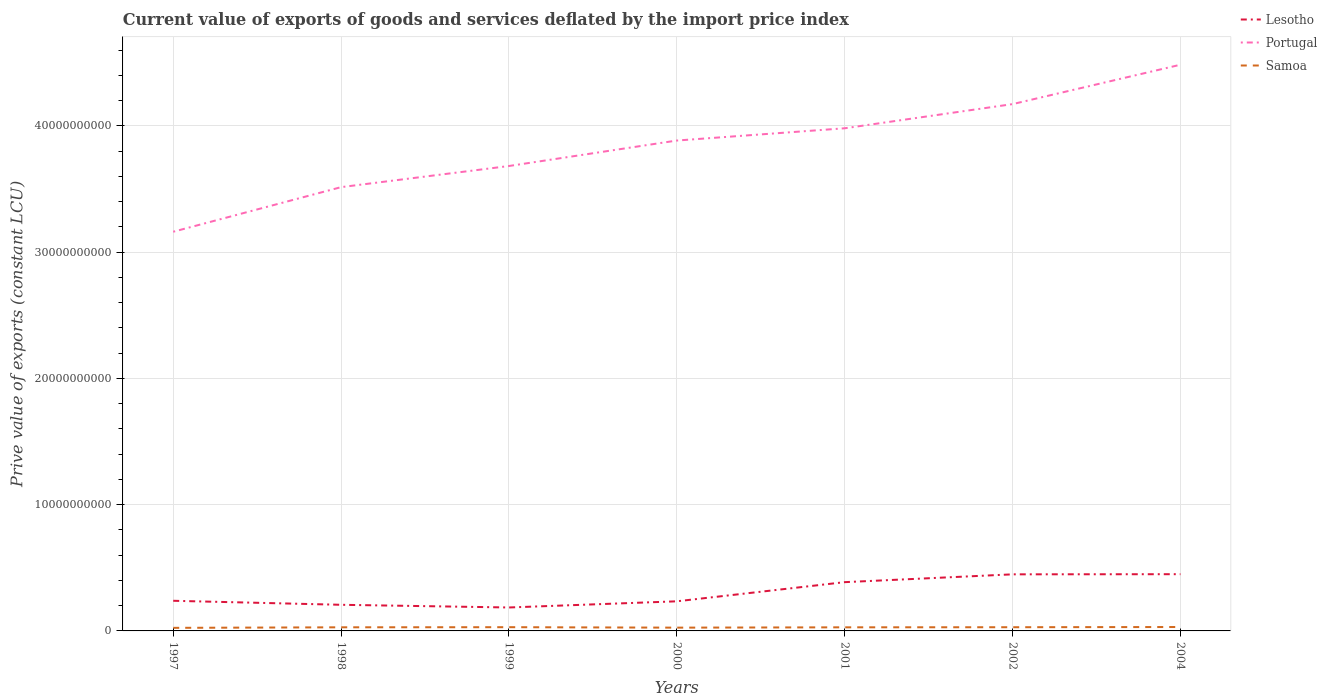How many different coloured lines are there?
Offer a very short reply. 3. Does the line corresponding to Portugal intersect with the line corresponding to Lesotho?
Provide a short and direct response. No. Across all years, what is the maximum prive value of exports in Samoa?
Provide a short and direct response. 2.44e+08. In which year was the prive value of exports in Samoa maximum?
Offer a terse response. 1997. What is the total prive value of exports in Samoa in the graph?
Provide a short and direct response. -2.47e+07. What is the difference between the highest and the second highest prive value of exports in Lesotho?
Your answer should be very brief. 2.64e+09. How many years are there in the graph?
Offer a terse response. 7. Are the values on the major ticks of Y-axis written in scientific E-notation?
Offer a terse response. No. Where does the legend appear in the graph?
Offer a very short reply. Top right. How many legend labels are there?
Offer a very short reply. 3. How are the legend labels stacked?
Your response must be concise. Vertical. What is the title of the graph?
Your answer should be very brief. Current value of exports of goods and services deflated by the import price index. What is the label or title of the X-axis?
Provide a succinct answer. Years. What is the label or title of the Y-axis?
Provide a short and direct response. Prive value of exports (constant LCU). What is the Prive value of exports (constant LCU) in Lesotho in 1997?
Give a very brief answer. 2.39e+09. What is the Prive value of exports (constant LCU) in Portugal in 1997?
Offer a very short reply. 3.16e+1. What is the Prive value of exports (constant LCU) in Samoa in 1997?
Your answer should be very brief. 2.44e+08. What is the Prive value of exports (constant LCU) of Lesotho in 1998?
Give a very brief answer. 2.07e+09. What is the Prive value of exports (constant LCU) in Portugal in 1998?
Keep it short and to the point. 3.52e+1. What is the Prive value of exports (constant LCU) in Samoa in 1998?
Your answer should be compact. 2.86e+08. What is the Prive value of exports (constant LCU) in Lesotho in 1999?
Give a very brief answer. 1.86e+09. What is the Prive value of exports (constant LCU) of Portugal in 1999?
Provide a succinct answer. 3.68e+1. What is the Prive value of exports (constant LCU) of Samoa in 1999?
Your answer should be very brief. 2.95e+08. What is the Prive value of exports (constant LCU) in Lesotho in 2000?
Your answer should be compact. 2.35e+09. What is the Prive value of exports (constant LCU) of Portugal in 2000?
Offer a very short reply. 3.88e+1. What is the Prive value of exports (constant LCU) of Samoa in 2000?
Give a very brief answer. 2.60e+08. What is the Prive value of exports (constant LCU) of Lesotho in 2001?
Give a very brief answer. 3.86e+09. What is the Prive value of exports (constant LCU) of Portugal in 2001?
Offer a very short reply. 3.98e+1. What is the Prive value of exports (constant LCU) in Samoa in 2001?
Make the answer very short. 2.85e+08. What is the Prive value of exports (constant LCU) in Lesotho in 2002?
Make the answer very short. 4.48e+09. What is the Prive value of exports (constant LCU) of Portugal in 2002?
Make the answer very short. 4.17e+1. What is the Prive value of exports (constant LCU) of Samoa in 2002?
Make the answer very short. 2.93e+08. What is the Prive value of exports (constant LCU) of Lesotho in 2004?
Your answer should be very brief. 4.49e+09. What is the Prive value of exports (constant LCU) in Portugal in 2004?
Your answer should be compact. 4.49e+1. What is the Prive value of exports (constant LCU) of Samoa in 2004?
Make the answer very short. 3.10e+08. Across all years, what is the maximum Prive value of exports (constant LCU) of Lesotho?
Your answer should be compact. 4.49e+09. Across all years, what is the maximum Prive value of exports (constant LCU) in Portugal?
Your response must be concise. 4.49e+1. Across all years, what is the maximum Prive value of exports (constant LCU) of Samoa?
Your answer should be very brief. 3.10e+08. Across all years, what is the minimum Prive value of exports (constant LCU) in Lesotho?
Offer a terse response. 1.86e+09. Across all years, what is the minimum Prive value of exports (constant LCU) of Portugal?
Your response must be concise. 3.16e+1. Across all years, what is the minimum Prive value of exports (constant LCU) in Samoa?
Offer a terse response. 2.44e+08. What is the total Prive value of exports (constant LCU) of Lesotho in the graph?
Provide a short and direct response. 2.15e+1. What is the total Prive value of exports (constant LCU) in Portugal in the graph?
Your response must be concise. 2.69e+11. What is the total Prive value of exports (constant LCU) of Samoa in the graph?
Keep it short and to the point. 1.97e+09. What is the difference between the Prive value of exports (constant LCU) of Lesotho in 1997 and that in 1998?
Keep it short and to the point. 3.17e+08. What is the difference between the Prive value of exports (constant LCU) in Portugal in 1997 and that in 1998?
Provide a succinct answer. -3.53e+09. What is the difference between the Prive value of exports (constant LCU) in Samoa in 1997 and that in 1998?
Keep it short and to the point. -4.23e+07. What is the difference between the Prive value of exports (constant LCU) of Lesotho in 1997 and that in 1999?
Provide a short and direct response. 5.31e+08. What is the difference between the Prive value of exports (constant LCU) in Portugal in 1997 and that in 1999?
Your answer should be very brief. -5.21e+09. What is the difference between the Prive value of exports (constant LCU) of Samoa in 1997 and that in 1999?
Make the answer very short. -5.15e+07. What is the difference between the Prive value of exports (constant LCU) of Lesotho in 1997 and that in 2000?
Your answer should be very brief. 4.17e+07. What is the difference between the Prive value of exports (constant LCU) of Portugal in 1997 and that in 2000?
Keep it short and to the point. -7.22e+09. What is the difference between the Prive value of exports (constant LCU) in Samoa in 1997 and that in 2000?
Provide a short and direct response. -1.63e+07. What is the difference between the Prive value of exports (constant LCU) in Lesotho in 1997 and that in 2001?
Provide a short and direct response. -1.48e+09. What is the difference between the Prive value of exports (constant LCU) of Portugal in 1997 and that in 2001?
Ensure brevity in your answer.  -8.20e+09. What is the difference between the Prive value of exports (constant LCU) of Samoa in 1997 and that in 2001?
Make the answer very short. -4.10e+07. What is the difference between the Prive value of exports (constant LCU) in Lesotho in 1997 and that in 2002?
Provide a succinct answer. -2.10e+09. What is the difference between the Prive value of exports (constant LCU) of Portugal in 1997 and that in 2002?
Make the answer very short. -1.01e+1. What is the difference between the Prive value of exports (constant LCU) in Samoa in 1997 and that in 2002?
Give a very brief answer. -4.91e+07. What is the difference between the Prive value of exports (constant LCU) of Lesotho in 1997 and that in 2004?
Your response must be concise. -2.11e+09. What is the difference between the Prive value of exports (constant LCU) in Portugal in 1997 and that in 2004?
Keep it short and to the point. -1.32e+1. What is the difference between the Prive value of exports (constant LCU) of Samoa in 1997 and that in 2004?
Ensure brevity in your answer.  -6.58e+07. What is the difference between the Prive value of exports (constant LCU) of Lesotho in 1998 and that in 1999?
Your response must be concise. 2.13e+08. What is the difference between the Prive value of exports (constant LCU) of Portugal in 1998 and that in 1999?
Keep it short and to the point. -1.67e+09. What is the difference between the Prive value of exports (constant LCU) of Samoa in 1998 and that in 1999?
Provide a succinct answer. -9.18e+06. What is the difference between the Prive value of exports (constant LCU) in Lesotho in 1998 and that in 2000?
Your answer should be compact. -2.76e+08. What is the difference between the Prive value of exports (constant LCU) of Portugal in 1998 and that in 2000?
Provide a succinct answer. -3.69e+09. What is the difference between the Prive value of exports (constant LCU) in Samoa in 1998 and that in 2000?
Ensure brevity in your answer.  2.60e+07. What is the difference between the Prive value of exports (constant LCU) in Lesotho in 1998 and that in 2001?
Keep it short and to the point. -1.79e+09. What is the difference between the Prive value of exports (constant LCU) in Portugal in 1998 and that in 2001?
Keep it short and to the point. -4.66e+09. What is the difference between the Prive value of exports (constant LCU) of Samoa in 1998 and that in 2001?
Give a very brief answer. 1.26e+06. What is the difference between the Prive value of exports (constant LCU) of Lesotho in 1998 and that in 2002?
Your answer should be compact. -2.41e+09. What is the difference between the Prive value of exports (constant LCU) of Portugal in 1998 and that in 2002?
Offer a very short reply. -6.58e+09. What is the difference between the Prive value of exports (constant LCU) of Samoa in 1998 and that in 2002?
Make the answer very short. -6.85e+06. What is the difference between the Prive value of exports (constant LCU) of Lesotho in 1998 and that in 2004?
Your response must be concise. -2.42e+09. What is the difference between the Prive value of exports (constant LCU) of Portugal in 1998 and that in 2004?
Make the answer very short. -9.70e+09. What is the difference between the Prive value of exports (constant LCU) of Samoa in 1998 and that in 2004?
Your answer should be compact. -2.35e+07. What is the difference between the Prive value of exports (constant LCU) in Lesotho in 1999 and that in 2000?
Your answer should be very brief. -4.89e+08. What is the difference between the Prive value of exports (constant LCU) in Portugal in 1999 and that in 2000?
Provide a succinct answer. -2.02e+09. What is the difference between the Prive value of exports (constant LCU) in Samoa in 1999 and that in 2000?
Make the answer very short. 3.52e+07. What is the difference between the Prive value of exports (constant LCU) in Lesotho in 1999 and that in 2001?
Give a very brief answer. -2.01e+09. What is the difference between the Prive value of exports (constant LCU) in Portugal in 1999 and that in 2001?
Provide a succinct answer. -2.99e+09. What is the difference between the Prive value of exports (constant LCU) of Samoa in 1999 and that in 2001?
Ensure brevity in your answer.  1.04e+07. What is the difference between the Prive value of exports (constant LCU) of Lesotho in 1999 and that in 2002?
Your response must be concise. -2.63e+09. What is the difference between the Prive value of exports (constant LCU) in Portugal in 1999 and that in 2002?
Ensure brevity in your answer.  -4.90e+09. What is the difference between the Prive value of exports (constant LCU) in Samoa in 1999 and that in 2002?
Provide a succinct answer. 2.34e+06. What is the difference between the Prive value of exports (constant LCU) of Lesotho in 1999 and that in 2004?
Offer a very short reply. -2.64e+09. What is the difference between the Prive value of exports (constant LCU) of Portugal in 1999 and that in 2004?
Offer a terse response. -8.02e+09. What is the difference between the Prive value of exports (constant LCU) of Samoa in 1999 and that in 2004?
Keep it short and to the point. -1.43e+07. What is the difference between the Prive value of exports (constant LCU) in Lesotho in 2000 and that in 2001?
Offer a very short reply. -1.52e+09. What is the difference between the Prive value of exports (constant LCU) of Portugal in 2000 and that in 2001?
Your response must be concise. -9.72e+08. What is the difference between the Prive value of exports (constant LCU) of Samoa in 2000 and that in 2001?
Offer a terse response. -2.48e+07. What is the difference between the Prive value of exports (constant LCU) of Lesotho in 2000 and that in 2002?
Keep it short and to the point. -2.14e+09. What is the difference between the Prive value of exports (constant LCU) in Portugal in 2000 and that in 2002?
Provide a succinct answer. -2.89e+09. What is the difference between the Prive value of exports (constant LCU) of Samoa in 2000 and that in 2002?
Provide a short and direct response. -3.29e+07. What is the difference between the Prive value of exports (constant LCU) of Lesotho in 2000 and that in 2004?
Your response must be concise. -2.15e+09. What is the difference between the Prive value of exports (constant LCU) in Portugal in 2000 and that in 2004?
Offer a terse response. -6.01e+09. What is the difference between the Prive value of exports (constant LCU) in Samoa in 2000 and that in 2004?
Your answer should be compact. -4.95e+07. What is the difference between the Prive value of exports (constant LCU) in Lesotho in 2001 and that in 2002?
Ensure brevity in your answer.  -6.19e+08. What is the difference between the Prive value of exports (constant LCU) in Portugal in 2001 and that in 2002?
Your answer should be compact. -1.91e+09. What is the difference between the Prive value of exports (constant LCU) of Samoa in 2001 and that in 2002?
Provide a short and direct response. -8.11e+06. What is the difference between the Prive value of exports (constant LCU) of Lesotho in 2001 and that in 2004?
Your answer should be compact. -6.31e+08. What is the difference between the Prive value of exports (constant LCU) of Portugal in 2001 and that in 2004?
Your response must be concise. -5.03e+09. What is the difference between the Prive value of exports (constant LCU) in Samoa in 2001 and that in 2004?
Your answer should be very brief. -2.47e+07. What is the difference between the Prive value of exports (constant LCU) in Lesotho in 2002 and that in 2004?
Your response must be concise. -1.13e+07. What is the difference between the Prive value of exports (constant LCU) of Portugal in 2002 and that in 2004?
Your response must be concise. -3.12e+09. What is the difference between the Prive value of exports (constant LCU) of Samoa in 2002 and that in 2004?
Your answer should be compact. -1.66e+07. What is the difference between the Prive value of exports (constant LCU) of Lesotho in 1997 and the Prive value of exports (constant LCU) of Portugal in 1998?
Your answer should be very brief. -3.28e+1. What is the difference between the Prive value of exports (constant LCU) in Lesotho in 1997 and the Prive value of exports (constant LCU) in Samoa in 1998?
Ensure brevity in your answer.  2.10e+09. What is the difference between the Prive value of exports (constant LCU) in Portugal in 1997 and the Prive value of exports (constant LCU) in Samoa in 1998?
Ensure brevity in your answer.  3.13e+1. What is the difference between the Prive value of exports (constant LCU) of Lesotho in 1997 and the Prive value of exports (constant LCU) of Portugal in 1999?
Give a very brief answer. -3.44e+1. What is the difference between the Prive value of exports (constant LCU) in Lesotho in 1997 and the Prive value of exports (constant LCU) in Samoa in 1999?
Offer a very short reply. 2.09e+09. What is the difference between the Prive value of exports (constant LCU) in Portugal in 1997 and the Prive value of exports (constant LCU) in Samoa in 1999?
Offer a terse response. 3.13e+1. What is the difference between the Prive value of exports (constant LCU) in Lesotho in 1997 and the Prive value of exports (constant LCU) in Portugal in 2000?
Give a very brief answer. -3.65e+1. What is the difference between the Prive value of exports (constant LCU) of Lesotho in 1997 and the Prive value of exports (constant LCU) of Samoa in 2000?
Offer a terse response. 2.13e+09. What is the difference between the Prive value of exports (constant LCU) in Portugal in 1997 and the Prive value of exports (constant LCU) in Samoa in 2000?
Offer a very short reply. 3.14e+1. What is the difference between the Prive value of exports (constant LCU) of Lesotho in 1997 and the Prive value of exports (constant LCU) of Portugal in 2001?
Your answer should be very brief. -3.74e+1. What is the difference between the Prive value of exports (constant LCU) in Lesotho in 1997 and the Prive value of exports (constant LCU) in Samoa in 2001?
Provide a succinct answer. 2.10e+09. What is the difference between the Prive value of exports (constant LCU) in Portugal in 1997 and the Prive value of exports (constant LCU) in Samoa in 2001?
Your answer should be compact. 3.13e+1. What is the difference between the Prive value of exports (constant LCU) of Lesotho in 1997 and the Prive value of exports (constant LCU) of Portugal in 2002?
Offer a terse response. -3.93e+1. What is the difference between the Prive value of exports (constant LCU) of Lesotho in 1997 and the Prive value of exports (constant LCU) of Samoa in 2002?
Keep it short and to the point. 2.09e+09. What is the difference between the Prive value of exports (constant LCU) of Portugal in 1997 and the Prive value of exports (constant LCU) of Samoa in 2002?
Ensure brevity in your answer.  3.13e+1. What is the difference between the Prive value of exports (constant LCU) of Lesotho in 1997 and the Prive value of exports (constant LCU) of Portugal in 2004?
Your response must be concise. -4.25e+1. What is the difference between the Prive value of exports (constant LCU) of Lesotho in 1997 and the Prive value of exports (constant LCU) of Samoa in 2004?
Keep it short and to the point. 2.08e+09. What is the difference between the Prive value of exports (constant LCU) in Portugal in 1997 and the Prive value of exports (constant LCU) in Samoa in 2004?
Ensure brevity in your answer.  3.13e+1. What is the difference between the Prive value of exports (constant LCU) in Lesotho in 1998 and the Prive value of exports (constant LCU) in Portugal in 1999?
Provide a short and direct response. -3.48e+1. What is the difference between the Prive value of exports (constant LCU) of Lesotho in 1998 and the Prive value of exports (constant LCU) of Samoa in 1999?
Provide a short and direct response. 1.77e+09. What is the difference between the Prive value of exports (constant LCU) of Portugal in 1998 and the Prive value of exports (constant LCU) of Samoa in 1999?
Ensure brevity in your answer.  3.49e+1. What is the difference between the Prive value of exports (constant LCU) in Lesotho in 1998 and the Prive value of exports (constant LCU) in Portugal in 2000?
Offer a terse response. -3.68e+1. What is the difference between the Prive value of exports (constant LCU) of Lesotho in 1998 and the Prive value of exports (constant LCU) of Samoa in 2000?
Offer a terse response. 1.81e+09. What is the difference between the Prive value of exports (constant LCU) of Portugal in 1998 and the Prive value of exports (constant LCU) of Samoa in 2000?
Provide a succinct answer. 3.49e+1. What is the difference between the Prive value of exports (constant LCU) of Lesotho in 1998 and the Prive value of exports (constant LCU) of Portugal in 2001?
Keep it short and to the point. -3.77e+1. What is the difference between the Prive value of exports (constant LCU) of Lesotho in 1998 and the Prive value of exports (constant LCU) of Samoa in 2001?
Your answer should be very brief. 1.79e+09. What is the difference between the Prive value of exports (constant LCU) in Portugal in 1998 and the Prive value of exports (constant LCU) in Samoa in 2001?
Ensure brevity in your answer.  3.49e+1. What is the difference between the Prive value of exports (constant LCU) in Lesotho in 1998 and the Prive value of exports (constant LCU) in Portugal in 2002?
Your answer should be compact. -3.97e+1. What is the difference between the Prive value of exports (constant LCU) in Lesotho in 1998 and the Prive value of exports (constant LCU) in Samoa in 2002?
Offer a very short reply. 1.78e+09. What is the difference between the Prive value of exports (constant LCU) of Portugal in 1998 and the Prive value of exports (constant LCU) of Samoa in 2002?
Offer a very short reply. 3.49e+1. What is the difference between the Prive value of exports (constant LCU) in Lesotho in 1998 and the Prive value of exports (constant LCU) in Portugal in 2004?
Give a very brief answer. -4.28e+1. What is the difference between the Prive value of exports (constant LCU) of Lesotho in 1998 and the Prive value of exports (constant LCU) of Samoa in 2004?
Your answer should be very brief. 1.76e+09. What is the difference between the Prive value of exports (constant LCU) of Portugal in 1998 and the Prive value of exports (constant LCU) of Samoa in 2004?
Your answer should be compact. 3.48e+1. What is the difference between the Prive value of exports (constant LCU) of Lesotho in 1999 and the Prive value of exports (constant LCU) of Portugal in 2000?
Keep it short and to the point. -3.70e+1. What is the difference between the Prive value of exports (constant LCU) of Lesotho in 1999 and the Prive value of exports (constant LCU) of Samoa in 2000?
Give a very brief answer. 1.60e+09. What is the difference between the Prive value of exports (constant LCU) of Portugal in 1999 and the Prive value of exports (constant LCU) of Samoa in 2000?
Provide a succinct answer. 3.66e+1. What is the difference between the Prive value of exports (constant LCU) of Lesotho in 1999 and the Prive value of exports (constant LCU) of Portugal in 2001?
Offer a terse response. -3.80e+1. What is the difference between the Prive value of exports (constant LCU) of Lesotho in 1999 and the Prive value of exports (constant LCU) of Samoa in 2001?
Your answer should be compact. 1.57e+09. What is the difference between the Prive value of exports (constant LCU) in Portugal in 1999 and the Prive value of exports (constant LCU) in Samoa in 2001?
Make the answer very short. 3.65e+1. What is the difference between the Prive value of exports (constant LCU) of Lesotho in 1999 and the Prive value of exports (constant LCU) of Portugal in 2002?
Offer a very short reply. -3.99e+1. What is the difference between the Prive value of exports (constant LCU) of Lesotho in 1999 and the Prive value of exports (constant LCU) of Samoa in 2002?
Your response must be concise. 1.56e+09. What is the difference between the Prive value of exports (constant LCU) of Portugal in 1999 and the Prive value of exports (constant LCU) of Samoa in 2002?
Ensure brevity in your answer.  3.65e+1. What is the difference between the Prive value of exports (constant LCU) in Lesotho in 1999 and the Prive value of exports (constant LCU) in Portugal in 2004?
Your answer should be compact. -4.30e+1. What is the difference between the Prive value of exports (constant LCU) of Lesotho in 1999 and the Prive value of exports (constant LCU) of Samoa in 2004?
Provide a succinct answer. 1.55e+09. What is the difference between the Prive value of exports (constant LCU) in Portugal in 1999 and the Prive value of exports (constant LCU) in Samoa in 2004?
Your response must be concise. 3.65e+1. What is the difference between the Prive value of exports (constant LCU) in Lesotho in 2000 and the Prive value of exports (constant LCU) in Portugal in 2001?
Provide a succinct answer. -3.75e+1. What is the difference between the Prive value of exports (constant LCU) in Lesotho in 2000 and the Prive value of exports (constant LCU) in Samoa in 2001?
Keep it short and to the point. 2.06e+09. What is the difference between the Prive value of exports (constant LCU) in Portugal in 2000 and the Prive value of exports (constant LCU) in Samoa in 2001?
Provide a succinct answer. 3.86e+1. What is the difference between the Prive value of exports (constant LCU) of Lesotho in 2000 and the Prive value of exports (constant LCU) of Portugal in 2002?
Keep it short and to the point. -3.94e+1. What is the difference between the Prive value of exports (constant LCU) of Lesotho in 2000 and the Prive value of exports (constant LCU) of Samoa in 2002?
Give a very brief answer. 2.05e+09. What is the difference between the Prive value of exports (constant LCU) of Portugal in 2000 and the Prive value of exports (constant LCU) of Samoa in 2002?
Your answer should be compact. 3.86e+1. What is the difference between the Prive value of exports (constant LCU) in Lesotho in 2000 and the Prive value of exports (constant LCU) in Portugal in 2004?
Your answer should be compact. -4.25e+1. What is the difference between the Prive value of exports (constant LCU) of Lesotho in 2000 and the Prive value of exports (constant LCU) of Samoa in 2004?
Provide a succinct answer. 2.04e+09. What is the difference between the Prive value of exports (constant LCU) in Portugal in 2000 and the Prive value of exports (constant LCU) in Samoa in 2004?
Make the answer very short. 3.85e+1. What is the difference between the Prive value of exports (constant LCU) in Lesotho in 2001 and the Prive value of exports (constant LCU) in Portugal in 2002?
Give a very brief answer. -3.79e+1. What is the difference between the Prive value of exports (constant LCU) of Lesotho in 2001 and the Prive value of exports (constant LCU) of Samoa in 2002?
Ensure brevity in your answer.  3.57e+09. What is the difference between the Prive value of exports (constant LCU) of Portugal in 2001 and the Prive value of exports (constant LCU) of Samoa in 2002?
Keep it short and to the point. 3.95e+1. What is the difference between the Prive value of exports (constant LCU) of Lesotho in 2001 and the Prive value of exports (constant LCU) of Portugal in 2004?
Give a very brief answer. -4.10e+1. What is the difference between the Prive value of exports (constant LCU) in Lesotho in 2001 and the Prive value of exports (constant LCU) in Samoa in 2004?
Provide a short and direct response. 3.55e+09. What is the difference between the Prive value of exports (constant LCU) of Portugal in 2001 and the Prive value of exports (constant LCU) of Samoa in 2004?
Give a very brief answer. 3.95e+1. What is the difference between the Prive value of exports (constant LCU) of Lesotho in 2002 and the Prive value of exports (constant LCU) of Portugal in 2004?
Provide a short and direct response. -4.04e+1. What is the difference between the Prive value of exports (constant LCU) in Lesotho in 2002 and the Prive value of exports (constant LCU) in Samoa in 2004?
Offer a terse response. 4.17e+09. What is the difference between the Prive value of exports (constant LCU) of Portugal in 2002 and the Prive value of exports (constant LCU) of Samoa in 2004?
Offer a very short reply. 4.14e+1. What is the average Prive value of exports (constant LCU) of Lesotho per year?
Offer a very short reply. 3.07e+09. What is the average Prive value of exports (constant LCU) in Portugal per year?
Offer a terse response. 3.84e+1. What is the average Prive value of exports (constant LCU) of Samoa per year?
Ensure brevity in your answer.  2.82e+08. In the year 1997, what is the difference between the Prive value of exports (constant LCU) in Lesotho and Prive value of exports (constant LCU) in Portugal?
Your response must be concise. -2.92e+1. In the year 1997, what is the difference between the Prive value of exports (constant LCU) of Lesotho and Prive value of exports (constant LCU) of Samoa?
Your answer should be very brief. 2.14e+09. In the year 1997, what is the difference between the Prive value of exports (constant LCU) of Portugal and Prive value of exports (constant LCU) of Samoa?
Give a very brief answer. 3.14e+1. In the year 1998, what is the difference between the Prive value of exports (constant LCU) in Lesotho and Prive value of exports (constant LCU) in Portugal?
Your answer should be compact. -3.31e+1. In the year 1998, what is the difference between the Prive value of exports (constant LCU) of Lesotho and Prive value of exports (constant LCU) of Samoa?
Ensure brevity in your answer.  1.78e+09. In the year 1998, what is the difference between the Prive value of exports (constant LCU) of Portugal and Prive value of exports (constant LCU) of Samoa?
Give a very brief answer. 3.49e+1. In the year 1999, what is the difference between the Prive value of exports (constant LCU) of Lesotho and Prive value of exports (constant LCU) of Portugal?
Your answer should be very brief. -3.50e+1. In the year 1999, what is the difference between the Prive value of exports (constant LCU) in Lesotho and Prive value of exports (constant LCU) in Samoa?
Offer a very short reply. 1.56e+09. In the year 1999, what is the difference between the Prive value of exports (constant LCU) of Portugal and Prive value of exports (constant LCU) of Samoa?
Make the answer very short. 3.65e+1. In the year 2000, what is the difference between the Prive value of exports (constant LCU) of Lesotho and Prive value of exports (constant LCU) of Portugal?
Offer a very short reply. -3.65e+1. In the year 2000, what is the difference between the Prive value of exports (constant LCU) in Lesotho and Prive value of exports (constant LCU) in Samoa?
Your response must be concise. 2.09e+09. In the year 2000, what is the difference between the Prive value of exports (constant LCU) in Portugal and Prive value of exports (constant LCU) in Samoa?
Provide a succinct answer. 3.86e+1. In the year 2001, what is the difference between the Prive value of exports (constant LCU) in Lesotho and Prive value of exports (constant LCU) in Portugal?
Your answer should be compact. -3.60e+1. In the year 2001, what is the difference between the Prive value of exports (constant LCU) in Lesotho and Prive value of exports (constant LCU) in Samoa?
Offer a terse response. 3.58e+09. In the year 2001, what is the difference between the Prive value of exports (constant LCU) in Portugal and Prive value of exports (constant LCU) in Samoa?
Your answer should be very brief. 3.95e+1. In the year 2002, what is the difference between the Prive value of exports (constant LCU) in Lesotho and Prive value of exports (constant LCU) in Portugal?
Offer a very short reply. -3.72e+1. In the year 2002, what is the difference between the Prive value of exports (constant LCU) in Lesotho and Prive value of exports (constant LCU) in Samoa?
Provide a succinct answer. 4.19e+09. In the year 2002, what is the difference between the Prive value of exports (constant LCU) in Portugal and Prive value of exports (constant LCU) in Samoa?
Offer a very short reply. 4.14e+1. In the year 2004, what is the difference between the Prive value of exports (constant LCU) in Lesotho and Prive value of exports (constant LCU) in Portugal?
Ensure brevity in your answer.  -4.04e+1. In the year 2004, what is the difference between the Prive value of exports (constant LCU) in Lesotho and Prive value of exports (constant LCU) in Samoa?
Keep it short and to the point. 4.18e+09. In the year 2004, what is the difference between the Prive value of exports (constant LCU) in Portugal and Prive value of exports (constant LCU) in Samoa?
Keep it short and to the point. 4.45e+1. What is the ratio of the Prive value of exports (constant LCU) in Lesotho in 1997 to that in 1998?
Ensure brevity in your answer.  1.15. What is the ratio of the Prive value of exports (constant LCU) in Portugal in 1997 to that in 1998?
Provide a short and direct response. 0.9. What is the ratio of the Prive value of exports (constant LCU) in Samoa in 1997 to that in 1998?
Your answer should be very brief. 0.85. What is the ratio of the Prive value of exports (constant LCU) in Lesotho in 1997 to that in 1999?
Offer a very short reply. 1.29. What is the ratio of the Prive value of exports (constant LCU) in Portugal in 1997 to that in 1999?
Your response must be concise. 0.86. What is the ratio of the Prive value of exports (constant LCU) in Samoa in 1997 to that in 1999?
Your response must be concise. 0.83. What is the ratio of the Prive value of exports (constant LCU) of Lesotho in 1997 to that in 2000?
Keep it short and to the point. 1.02. What is the ratio of the Prive value of exports (constant LCU) in Portugal in 1997 to that in 2000?
Your answer should be compact. 0.81. What is the ratio of the Prive value of exports (constant LCU) of Samoa in 1997 to that in 2000?
Provide a succinct answer. 0.94. What is the ratio of the Prive value of exports (constant LCU) in Lesotho in 1997 to that in 2001?
Provide a succinct answer. 0.62. What is the ratio of the Prive value of exports (constant LCU) of Portugal in 1997 to that in 2001?
Ensure brevity in your answer.  0.79. What is the ratio of the Prive value of exports (constant LCU) of Samoa in 1997 to that in 2001?
Your answer should be compact. 0.86. What is the ratio of the Prive value of exports (constant LCU) of Lesotho in 1997 to that in 2002?
Your answer should be compact. 0.53. What is the ratio of the Prive value of exports (constant LCU) of Portugal in 1997 to that in 2002?
Your answer should be compact. 0.76. What is the ratio of the Prive value of exports (constant LCU) of Samoa in 1997 to that in 2002?
Your response must be concise. 0.83. What is the ratio of the Prive value of exports (constant LCU) of Lesotho in 1997 to that in 2004?
Keep it short and to the point. 0.53. What is the ratio of the Prive value of exports (constant LCU) of Portugal in 1997 to that in 2004?
Your response must be concise. 0.7. What is the ratio of the Prive value of exports (constant LCU) in Samoa in 1997 to that in 2004?
Keep it short and to the point. 0.79. What is the ratio of the Prive value of exports (constant LCU) of Lesotho in 1998 to that in 1999?
Offer a terse response. 1.11. What is the ratio of the Prive value of exports (constant LCU) of Portugal in 1998 to that in 1999?
Ensure brevity in your answer.  0.95. What is the ratio of the Prive value of exports (constant LCU) of Samoa in 1998 to that in 1999?
Ensure brevity in your answer.  0.97. What is the ratio of the Prive value of exports (constant LCU) of Lesotho in 1998 to that in 2000?
Ensure brevity in your answer.  0.88. What is the ratio of the Prive value of exports (constant LCU) in Portugal in 1998 to that in 2000?
Provide a succinct answer. 0.91. What is the ratio of the Prive value of exports (constant LCU) in Samoa in 1998 to that in 2000?
Your answer should be compact. 1.1. What is the ratio of the Prive value of exports (constant LCU) of Lesotho in 1998 to that in 2001?
Ensure brevity in your answer.  0.54. What is the ratio of the Prive value of exports (constant LCU) in Portugal in 1998 to that in 2001?
Ensure brevity in your answer.  0.88. What is the ratio of the Prive value of exports (constant LCU) of Samoa in 1998 to that in 2001?
Your answer should be very brief. 1. What is the ratio of the Prive value of exports (constant LCU) of Lesotho in 1998 to that in 2002?
Offer a terse response. 0.46. What is the ratio of the Prive value of exports (constant LCU) in Portugal in 1998 to that in 2002?
Your response must be concise. 0.84. What is the ratio of the Prive value of exports (constant LCU) of Samoa in 1998 to that in 2002?
Your response must be concise. 0.98. What is the ratio of the Prive value of exports (constant LCU) in Lesotho in 1998 to that in 2004?
Give a very brief answer. 0.46. What is the ratio of the Prive value of exports (constant LCU) in Portugal in 1998 to that in 2004?
Offer a very short reply. 0.78. What is the ratio of the Prive value of exports (constant LCU) in Samoa in 1998 to that in 2004?
Keep it short and to the point. 0.92. What is the ratio of the Prive value of exports (constant LCU) in Lesotho in 1999 to that in 2000?
Your answer should be compact. 0.79. What is the ratio of the Prive value of exports (constant LCU) in Portugal in 1999 to that in 2000?
Your response must be concise. 0.95. What is the ratio of the Prive value of exports (constant LCU) in Samoa in 1999 to that in 2000?
Offer a very short reply. 1.14. What is the ratio of the Prive value of exports (constant LCU) in Lesotho in 1999 to that in 2001?
Give a very brief answer. 0.48. What is the ratio of the Prive value of exports (constant LCU) of Portugal in 1999 to that in 2001?
Give a very brief answer. 0.92. What is the ratio of the Prive value of exports (constant LCU) of Samoa in 1999 to that in 2001?
Your answer should be compact. 1.04. What is the ratio of the Prive value of exports (constant LCU) of Lesotho in 1999 to that in 2002?
Ensure brevity in your answer.  0.41. What is the ratio of the Prive value of exports (constant LCU) in Portugal in 1999 to that in 2002?
Your answer should be compact. 0.88. What is the ratio of the Prive value of exports (constant LCU) of Lesotho in 1999 to that in 2004?
Give a very brief answer. 0.41. What is the ratio of the Prive value of exports (constant LCU) of Portugal in 1999 to that in 2004?
Give a very brief answer. 0.82. What is the ratio of the Prive value of exports (constant LCU) in Samoa in 1999 to that in 2004?
Your answer should be very brief. 0.95. What is the ratio of the Prive value of exports (constant LCU) of Lesotho in 2000 to that in 2001?
Give a very brief answer. 0.61. What is the ratio of the Prive value of exports (constant LCU) in Portugal in 2000 to that in 2001?
Offer a terse response. 0.98. What is the ratio of the Prive value of exports (constant LCU) of Samoa in 2000 to that in 2001?
Ensure brevity in your answer.  0.91. What is the ratio of the Prive value of exports (constant LCU) in Lesotho in 2000 to that in 2002?
Provide a short and direct response. 0.52. What is the ratio of the Prive value of exports (constant LCU) of Portugal in 2000 to that in 2002?
Your answer should be compact. 0.93. What is the ratio of the Prive value of exports (constant LCU) in Samoa in 2000 to that in 2002?
Offer a very short reply. 0.89. What is the ratio of the Prive value of exports (constant LCU) of Lesotho in 2000 to that in 2004?
Offer a very short reply. 0.52. What is the ratio of the Prive value of exports (constant LCU) of Portugal in 2000 to that in 2004?
Provide a succinct answer. 0.87. What is the ratio of the Prive value of exports (constant LCU) of Samoa in 2000 to that in 2004?
Keep it short and to the point. 0.84. What is the ratio of the Prive value of exports (constant LCU) in Lesotho in 2001 to that in 2002?
Your response must be concise. 0.86. What is the ratio of the Prive value of exports (constant LCU) of Portugal in 2001 to that in 2002?
Your answer should be compact. 0.95. What is the ratio of the Prive value of exports (constant LCU) in Samoa in 2001 to that in 2002?
Ensure brevity in your answer.  0.97. What is the ratio of the Prive value of exports (constant LCU) of Lesotho in 2001 to that in 2004?
Your response must be concise. 0.86. What is the ratio of the Prive value of exports (constant LCU) in Portugal in 2001 to that in 2004?
Provide a short and direct response. 0.89. What is the ratio of the Prive value of exports (constant LCU) in Samoa in 2001 to that in 2004?
Give a very brief answer. 0.92. What is the ratio of the Prive value of exports (constant LCU) of Lesotho in 2002 to that in 2004?
Offer a terse response. 1. What is the ratio of the Prive value of exports (constant LCU) of Portugal in 2002 to that in 2004?
Make the answer very short. 0.93. What is the ratio of the Prive value of exports (constant LCU) in Samoa in 2002 to that in 2004?
Ensure brevity in your answer.  0.95. What is the difference between the highest and the second highest Prive value of exports (constant LCU) in Lesotho?
Your answer should be compact. 1.13e+07. What is the difference between the highest and the second highest Prive value of exports (constant LCU) in Portugal?
Make the answer very short. 3.12e+09. What is the difference between the highest and the second highest Prive value of exports (constant LCU) in Samoa?
Offer a terse response. 1.43e+07. What is the difference between the highest and the lowest Prive value of exports (constant LCU) of Lesotho?
Your response must be concise. 2.64e+09. What is the difference between the highest and the lowest Prive value of exports (constant LCU) in Portugal?
Provide a succinct answer. 1.32e+1. What is the difference between the highest and the lowest Prive value of exports (constant LCU) of Samoa?
Give a very brief answer. 6.58e+07. 